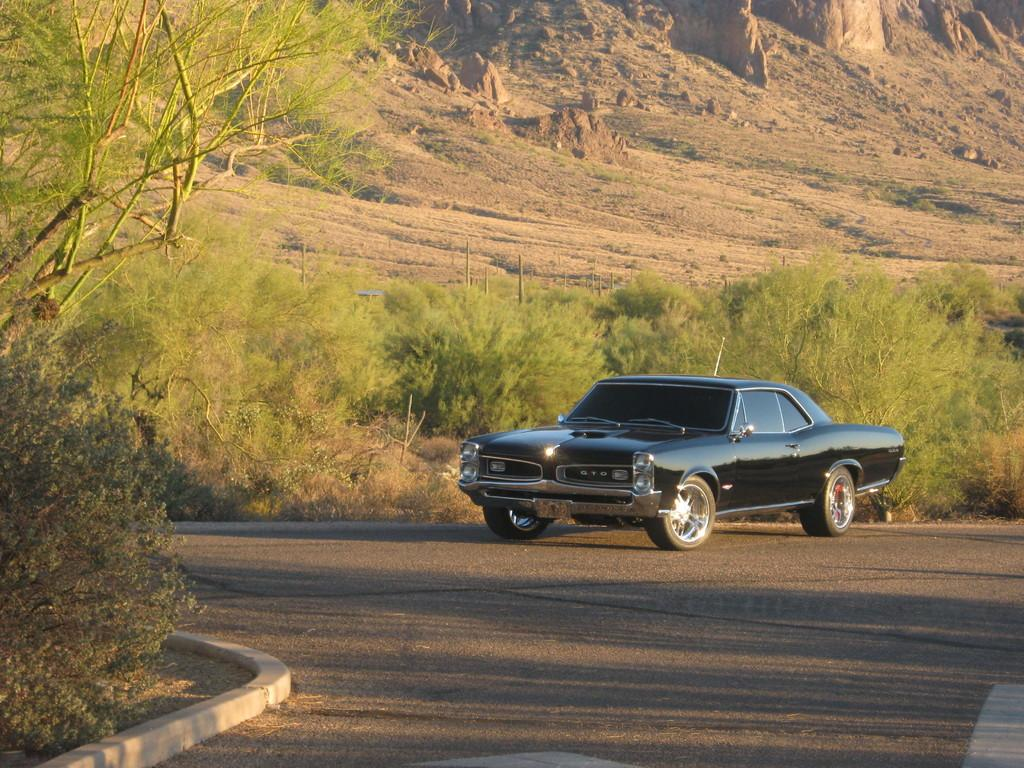What type of vegetation can be seen in the image? There are plants, trees, and grass in the image. What type of terrain is visible in the image? There is sand in the image. What is the chance of winning the rail in the image? There is no rail or game of chance present in the image. 